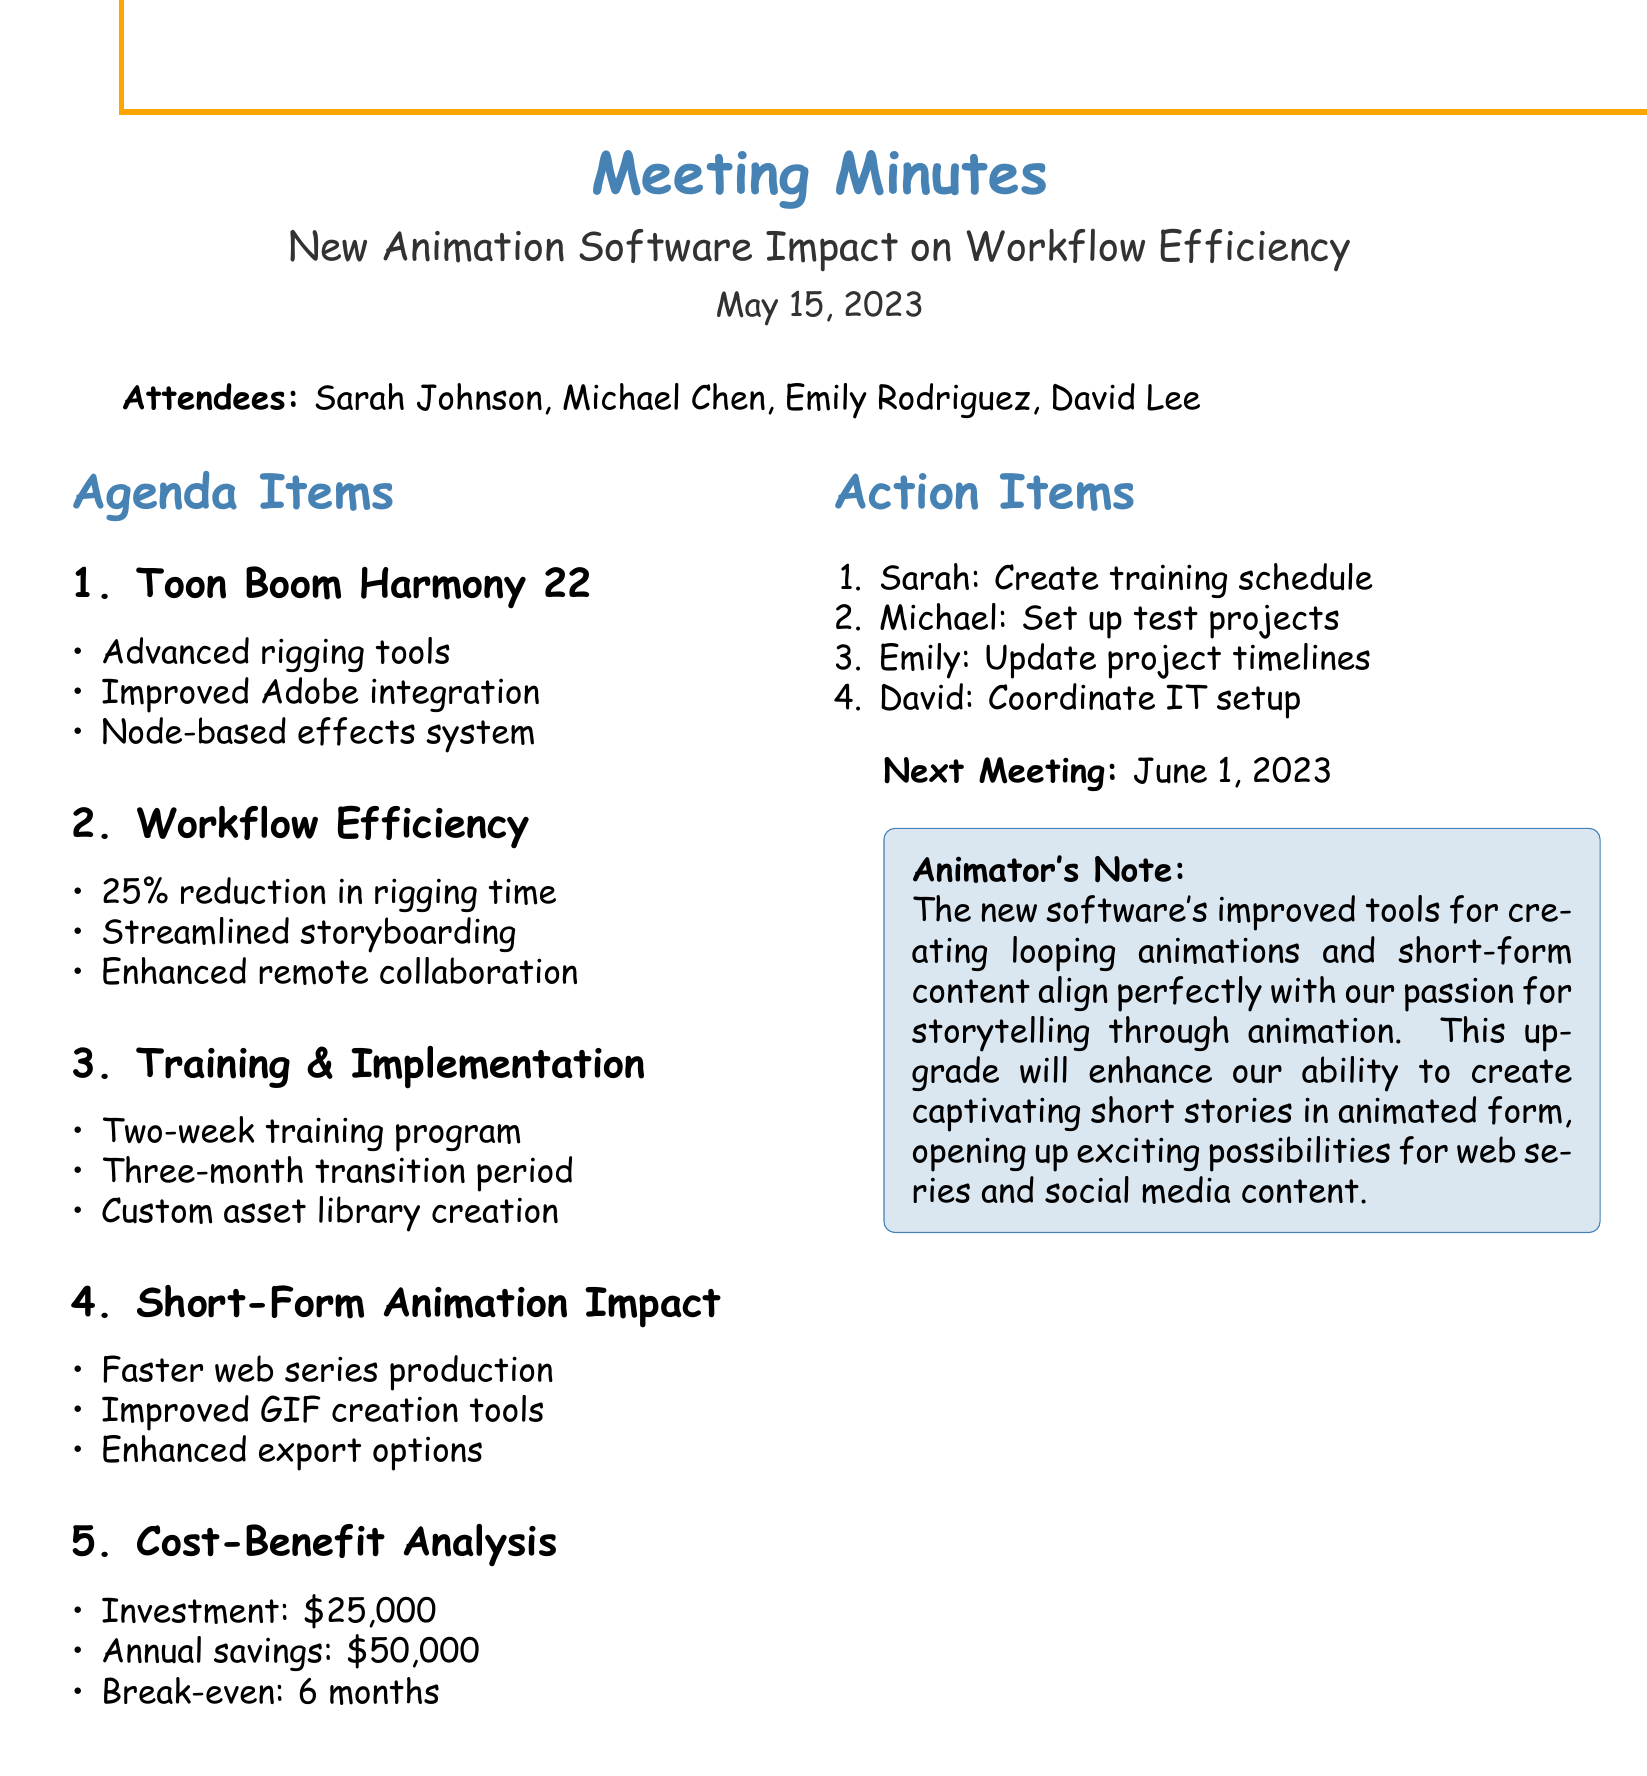What is the date of the meeting? The date of the meeting is provided in the document as May 15, 2023.
Answer: May 15, 2023 Who is the Lead Animator? Sarah Johnson is listed as the Lead Animator in the attendees section of the document.
Answer: Sarah Johnson What is the estimated reduction in rigging time? The document states that there is an estimated 25% reduction in rigging time.
Answer: 25% What major software was introduced during the meeting? Toon Boom Harmony 22 is the major software introduced in the document.
Answer: Toon Boom Harmony 22 What is the initial investment for the software licenses and training? The document outlines the initial investment as $25,000.
Answer: $25,000 How long is the training program for animators? The document specifies that there will be a two-week training program for all animators.
Answer: Two weeks What is the expected break-even point after full implementation? The expected break-even point mentioned in the document is 6 months after full implementation.
Answer: 6 months What is one key feature of the new software related to collaboration? Enhanced multi-user collaboration features for remote teams is noted as a key feature in the document.
Answer: Enhanced multi-user collaboration What specific impact does the new software have on short-form animation projects? The document states it has the potential for faster turnaround on web series and social media content.
Answer: Faster turnaround on web series and social media content What action item is assigned to Sarah? Sarah is tasked with creating a detailed training schedule by next week.
Answer: Create a detailed training schedule 